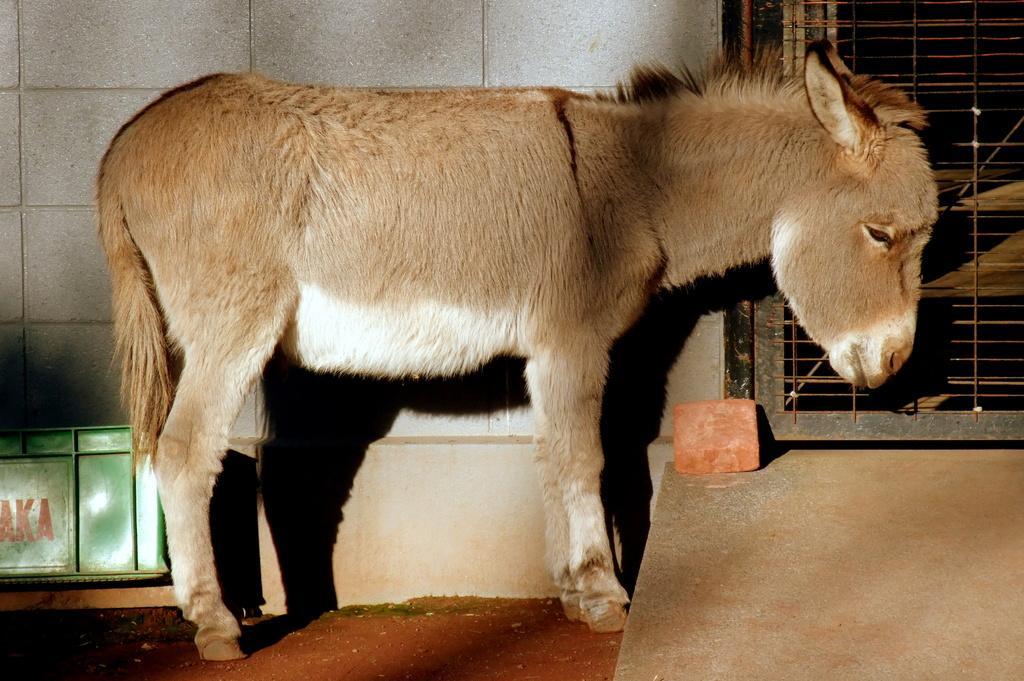Can you describe this image briefly? In the picture we can see donkey, crate, red color brick and in the background of the picture there is a wall, Iron gate. 